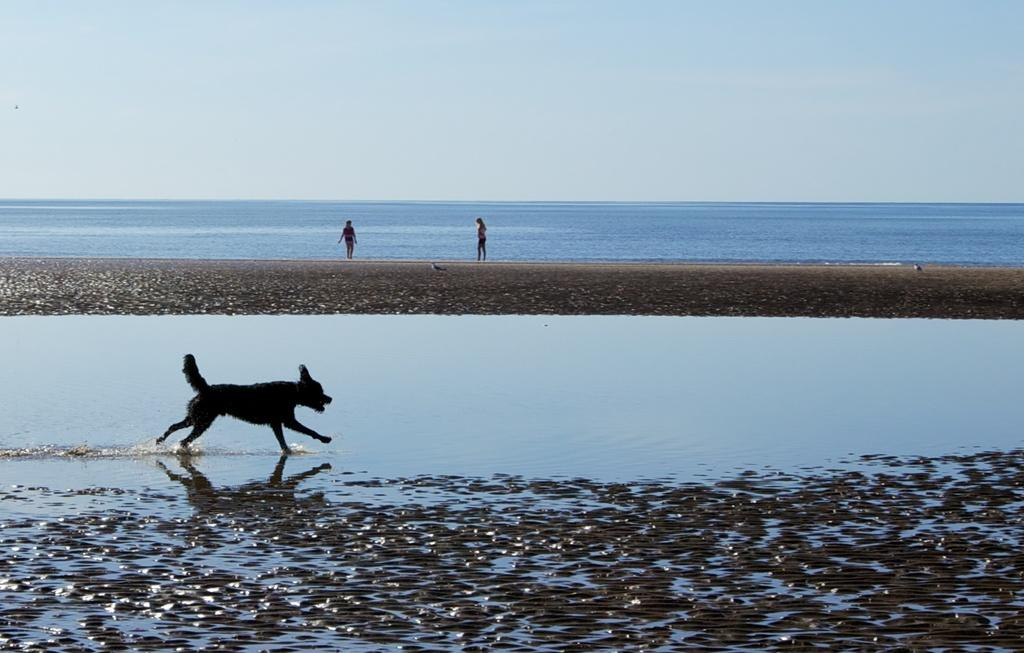What animal can be seen in the image? There is a dog in the image. What is the dog doing in the image? The dog is running in the water. How many people are present in the image? There are two women in the image. What is the weather like in the image? The sky is cloudy in the image. What type of leaf can be seen falling from the picture in the image? There is no picture present in the image, nor is there a leaf falling. 